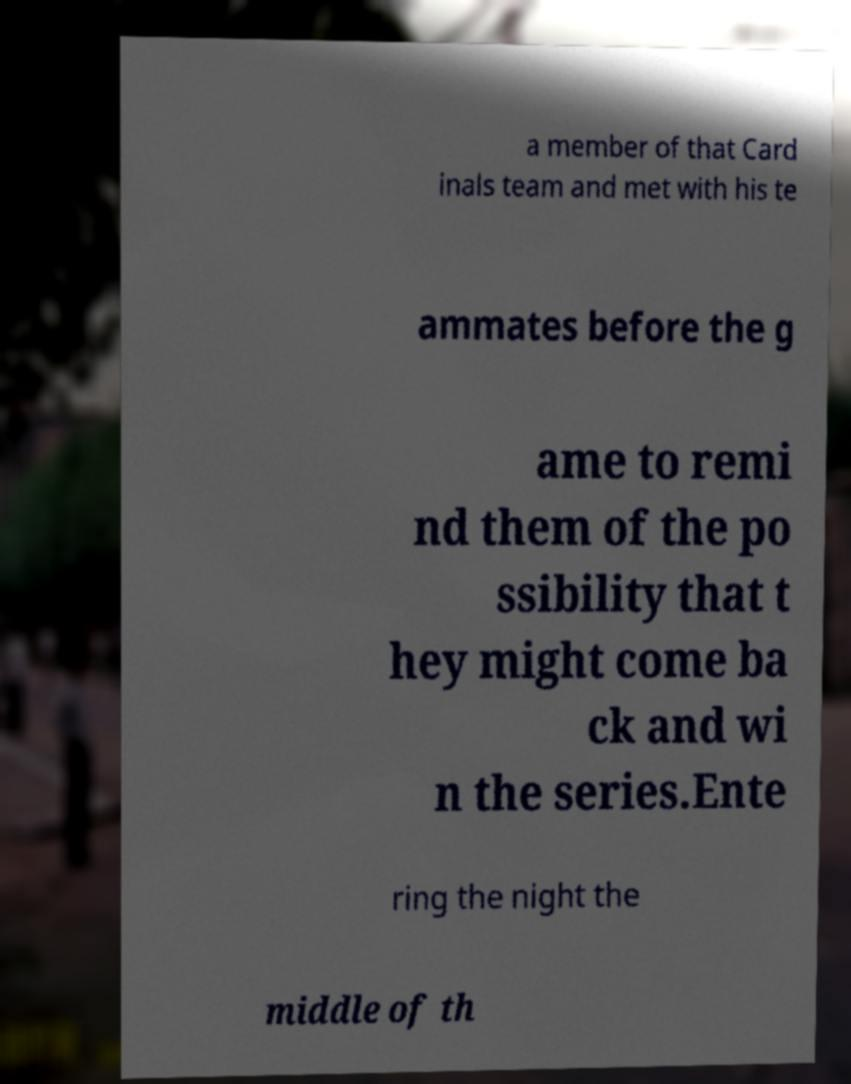For documentation purposes, I need the text within this image transcribed. Could you provide that? a member of that Card inals team and met with his te ammates before the g ame to remi nd them of the po ssibility that t hey might come ba ck and wi n the series.Ente ring the night the middle of th 